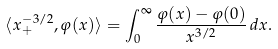<formula> <loc_0><loc_0><loc_500><loc_500>\langle x _ { + } ^ { - 3 / 2 } , \varphi ( x ) \rangle = \int _ { 0 } ^ { \infty } \frac { \varphi ( x ) - \varphi ( 0 ) } { x ^ { 3 / 2 } } \, d x .</formula> 